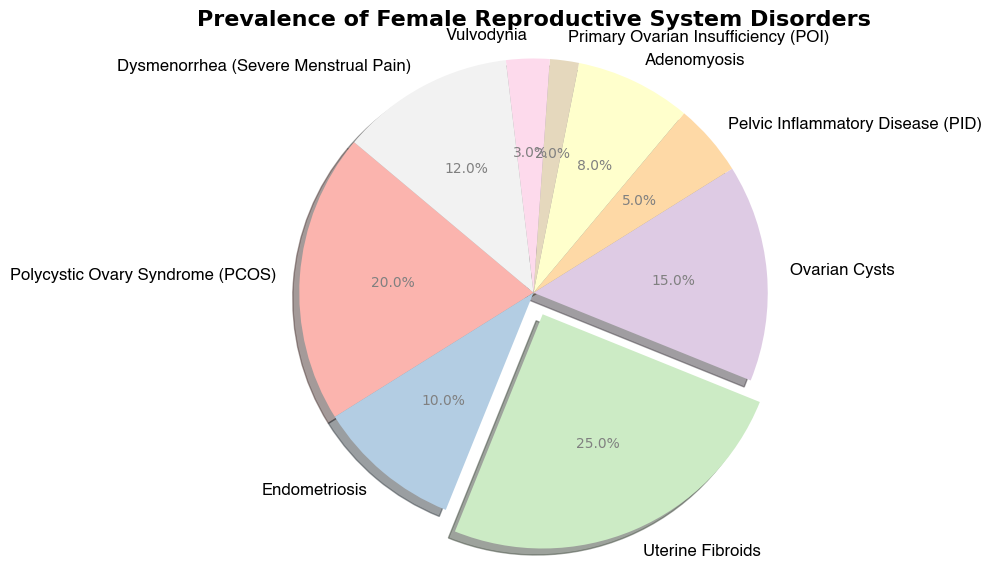What's the most prevalent female reproductive disorder shown in the pie chart? The chart shows the prevalence percentage for each disorder. The slice with the largest percentage is identified as "Uterine Fibroids" with 25%.
Answer: Uterine Fibroids Which disorder has the lowest prevalence, and what is its percentage? The slice representing the smallest percentage is "Primary Ovarian Insufficiency (POI)" with 2%.
Answer: Primary Ovarian Insufficiency (POI), 2% How much more prevalent are Uterine Fibroids compared to Vulvodynia? Uterine Fibroids are at 25% while Vulvodynia is at 3%. The difference is 25% - 3% = 22%.
Answer: 22% Combine the prevalence of Endometriosis and Pelvic Inflammatory Disease (PID). What is the total percentage? Endometriosis has a prevalence of 10% and PID has 5%. Adding these together: 10% + 5% = 15%.
Answer: 15% Which disorders together make up exactly half (50%) of the total prevalence? Adding the prevalence of Uterine Fibroids (25%), Polycystic Ovary Syndrome (PCOS) (20%), and Primary Ovarian Insufficiency (POI) (2%) gives 47%, while adding Uterine Fibroids (25%) and Ovarian Cysts (15%) gives 40%. Finally, adding Uterine Fibroids (25%) and Dysmenorrhea (12%) gives 37%. The correct combination does not exist in the data; none add exactly to 50%.
Answer: None Out of Endometriosis and Adenomyosis, which disorder has a lesser prevalence and by how much? Endometriosis is 10% and Adenomyosis is 8%. The difference is 10% - 8% = 2%.
Answer: Adenomyosis, 2% What percentage of disorders have a prevalence equal to or above 10%? Disorders with prevalence equal to or above 10% are Polycystic Ovary Syndrome (20%), Endometriosis (10%), Uterine Fibroids (25%), Ovarian Cysts (15%), and Dysmenorrhea (12%). So, 5 disorders. Since there are 9 disorders total, (5/9) * 100 ≈ 55.6%.
Answer: 55.6% What is the total prevalence percentage of disorders that are less than or equal to 10%? Adding the percentages of disorders less than or equal to 10%: Endometriosis (10%) + Pelvic Inflammatory Disease (5%) + Adenomyosis (8%) + Primary Ovarian Insufficiency (2%) + Vulvodynia (3%) = 28%.
Answer: 28% Which color represents the most prevalent disorder, and what is the percentage represented by that pie slice? The color with the largest slice corresponds to Uterine Fibroids, which is 25%. The actual color depends on the Pastel1 colormap settings, but for interpretation, focus on the pie slice size.
Answer: Uterine Fibroids, 25% 